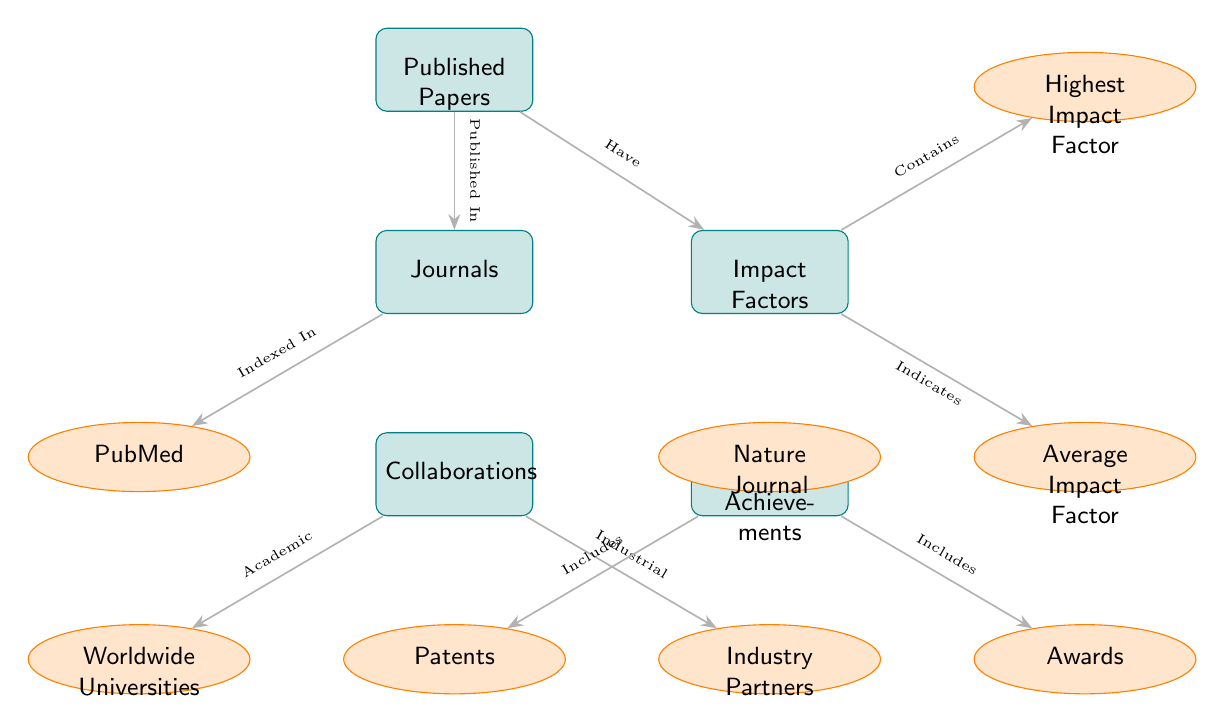What are the main categories represented in the diagram? The diagram represents four main categories: Published Papers, Journals, Impact Factors, Collaborations, and Notable Achievements. Counting the main nodes visually confirms these categories.
Answer: Published Papers, Journals, Impact Factors, Collaborations, Notable Achievements How many sub-nodes are connected to Journals? The diagram shows two sub-nodes directly connected to the Journals node: PubMed and Nature Journal. Thus, counting these sub-nodes gives the answer.
Answer: 2 Which category does the Highest Impact Factor belong to? The Highest Impact Factor is represented as a sub-node connected to the Impact Factors node. Tracing the flow of the diagram leads to this conclusion.
Answer: Impact Factors What types of collaborations are shown in the diagram? Two types of collaborations are indicated as sub-nodes: Worldwide Universities and Industry Partners. These indicate the nature of the collaborations described in the diagram.
Answer: Worldwide Universities, Industry Partners What do Notable Achievements include? The Notable Achievements category includes two specific sub-nodes: Patents and Awards. By observing the connections leading to these nodes, the answer can be derived.
Answer: Patents, Awards Which node is indicative of the research impact? The Impact Factors node directly represents the research impact, as evidenced by its positioning in the diagram and the label.
Answer: Impact Factors What relationship is indicated between Published Papers and Journals? The relationship indicates that Published Papers are "Published In" Journals, as shown by the connecting edge labeled with this phrasing in the diagram.
Answer: Published In Are the Average Impact Factor and Highest Impact Factor part of the same category? Yes, both the Average Impact Factor and the Highest Impact Factor are sub-nodes of the same category, which is Impact Factors. This can be confirmed by inspecting their connections.
Answer: Yes 